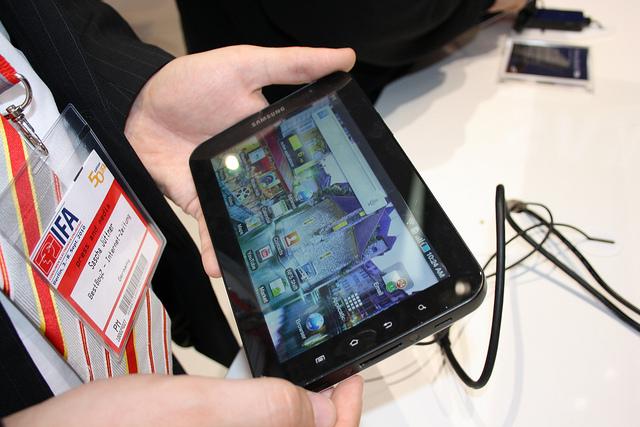What name is on the name tag shown in the scene?
Answer briefly. Sasha. Is this an iPad?
Quick response, please. No. Does the top hand belong to the same person as the bottom hand?
Keep it brief. Yes. 